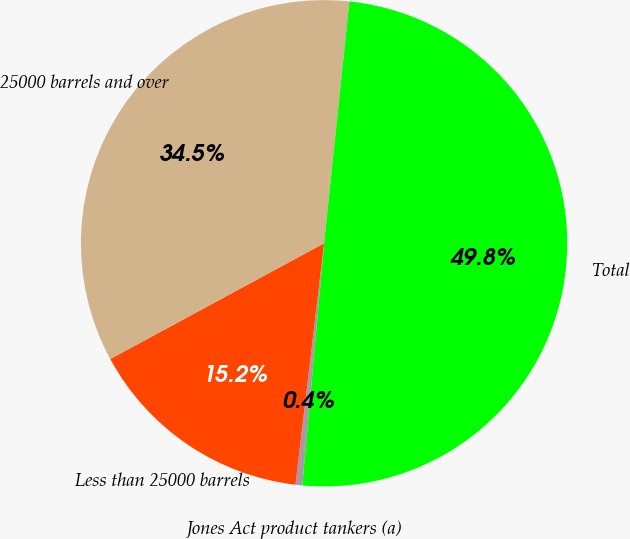Convert chart to OTSL. <chart><loc_0><loc_0><loc_500><loc_500><pie_chart><fcel>Jones Act product tankers (a)<fcel>Less than 25000 barrels<fcel>25000 barrels and over<fcel>Total<nl><fcel>0.45%<fcel>15.23%<fcel>34.55%<fcel>49.77%<nl></chart> 